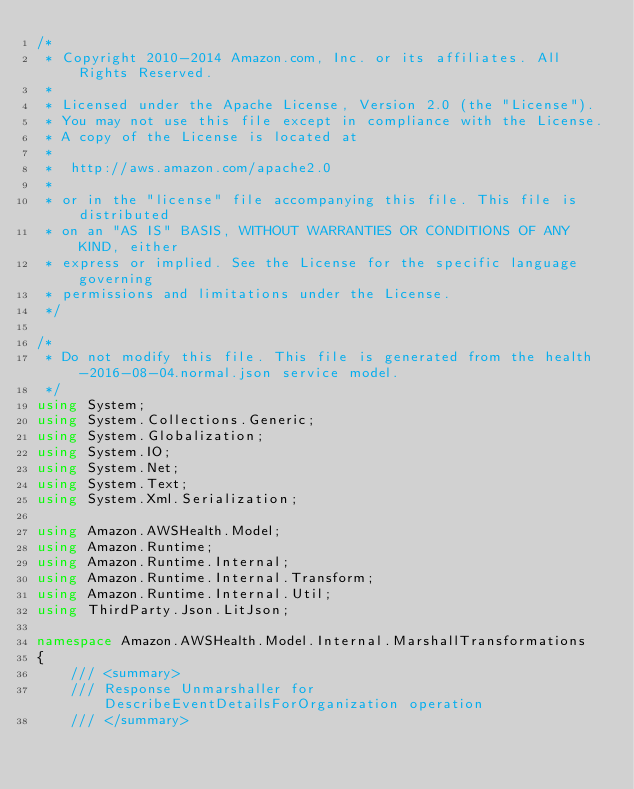Convert code to text. <code><loc_0><loc_0><loc_500><loc_500><_C#_>/*
 * Copyright 2010-2014 Amazon.com, Inc. or its affiliates. All Rights Reserved.
 * 
 * Licensed under the Apache License, Version 2.0 (the "License").
 * You may not use this file except in compliance with the License.
 * A copy of the License is located at
 * 
 *  http://aws.amazon.com/apache2.0
 * 
 * or in the "license" file accompanying this file. This file is distributed
 * on an "AS IS" BASIS, WITHOUT WARRANTIES OR CONDITIONS OF ANY KIND, either
 * express or implied. See the License for the specific language governing
 * permissions and limitations under the License.
 */

/*
 * Do not modify this file. This file is generated from the health-2016-08-04.normal.json service model.
 */
using System;
using System.Collections.Generic;
using System.Globalization;
using System.IO;
using System.Net;
using System.Text;
using System.Xml.Serialization;

using Amazon.AWSHealth.Model;
using Amazon.Runtime;
using Amazon.Runtime.Internal;
using Amazon.Runtime.Internal.Transform;
using Amazon.Runtime.Internal.Util;
using ThirdParty.Json.LitJson;

namespace Amazon.AWSHealth.Model.Internal.MarshallTransformations
{
    /// <summary>
    /// Response Unmarshaller for DescribeEventDetailsForOrganization operation
    /// </summary>  </code> 